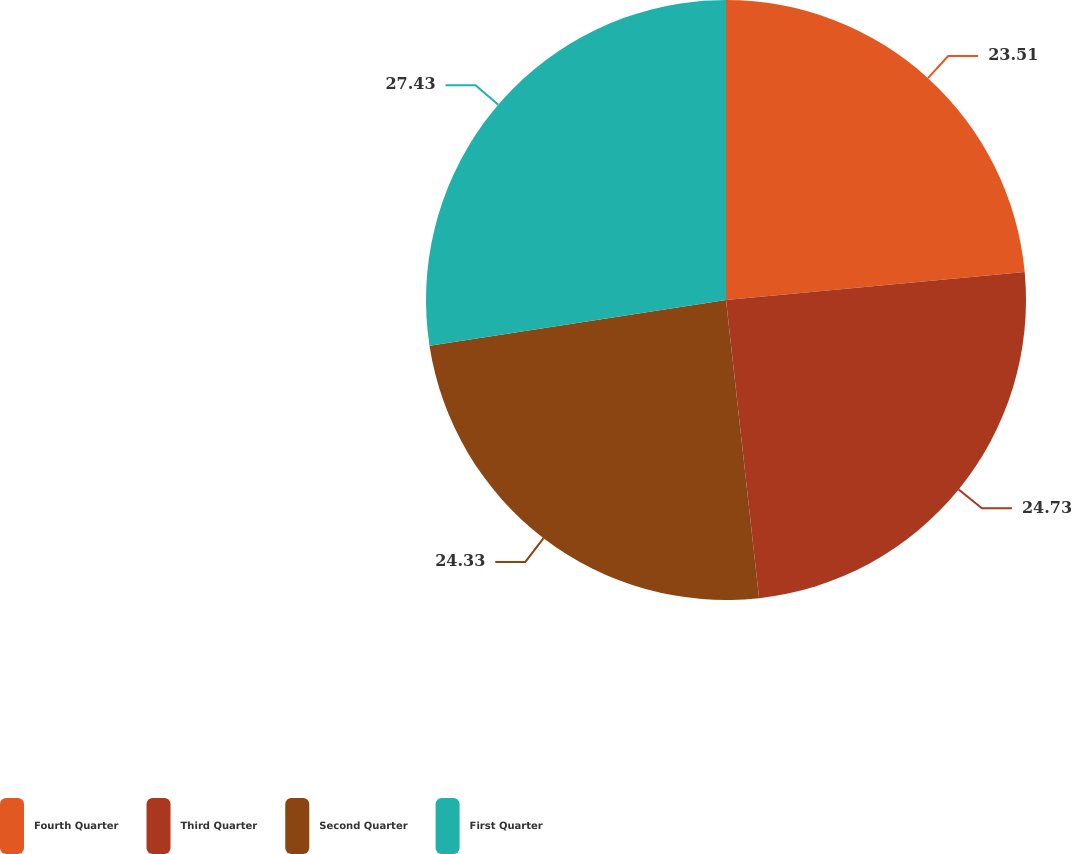Convert chart. <chart><loc_0><loc_0><loc_500><loc_500><pie_chart><fcel>Fourth Quarter<fcel>Third Quarter<fcel>Second Quarter<fcel>First Quarter<nl><fcel>23.51%<fcel>24.73%<fcel>24.33%<fcel>27.43%<nl></chart> 